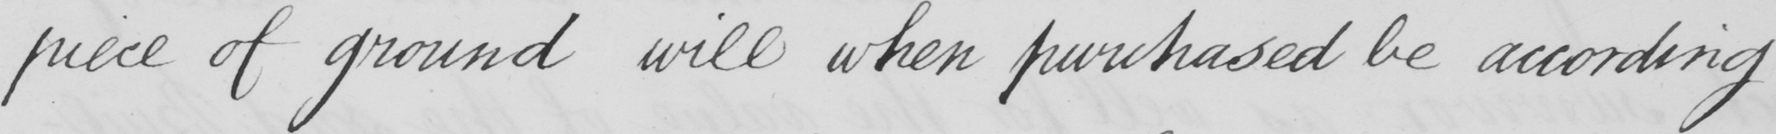What text is written in this handwritten line? piece of ground will when purchased be according 